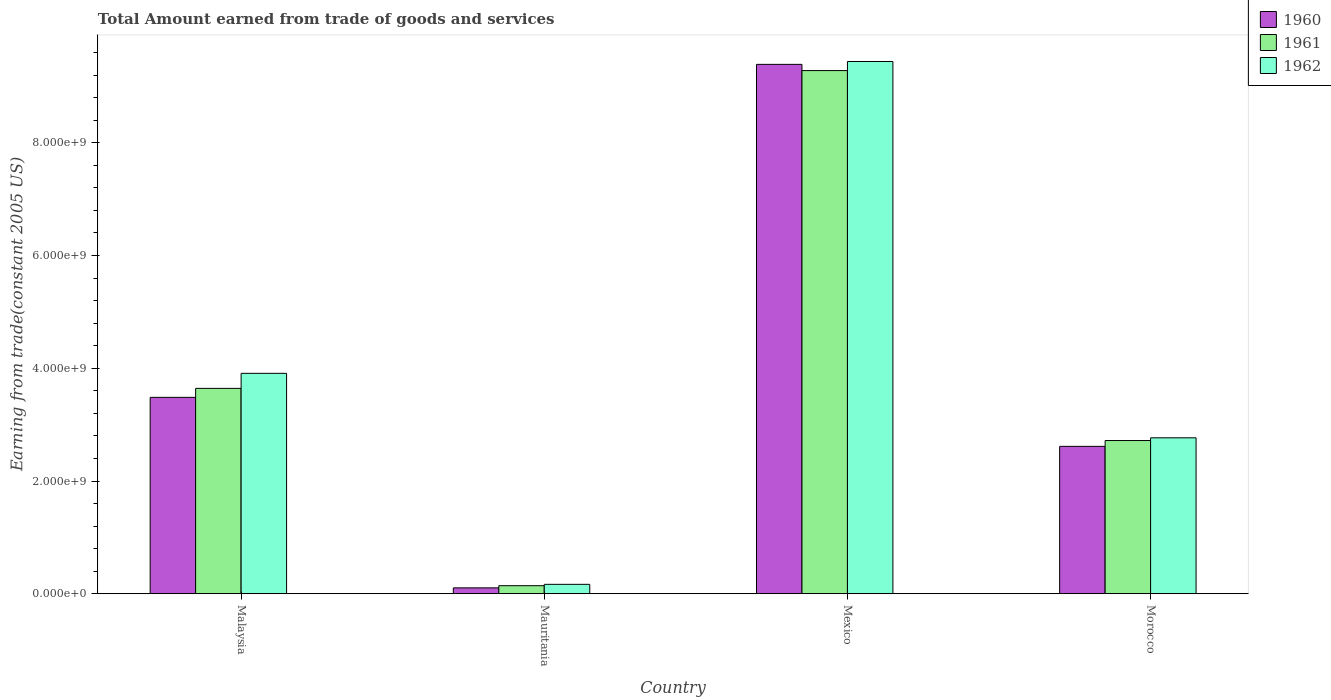How many different coloured bars are there?
Give a very brief answer. 3. Are the number of bars per tick equal to the number of legend labels?
Your answer should be compact. Yes. How many bars are there on the 3rd tick from the left?
Give a very brief answer. 3. How many bars are there on the 2nd tick from the right?
Provide a succinct answer. 3. In how many cases, is the number of bars for a given country not equal to the number of legend labels?
Give a very brief answer. 0. What is the total amount earned by trading goods and services in 1960 in Morocco?
Your response must be concise. 2.61e+09. Across all countries, what is the maximum total amount earned by trading goods and services in 1960?
Offer a terse response. 9.39e+09. Across all countries, what is the minimum total amount earned by trading goods and services in 1960?
Ensure brevity in your answer.  1.04e+08. In which country was the total amount earned by trading goods and services in 1962 maximum?
Your answer should be compact. Mexico. In which country was the total amount earned by trading goods and services in 1960 minimum?
Your answer should be compact. Mauritania. What is the total total amount earned by trading goods and services in 1961 in the graph?
Give a very brief answer. 1.58e+1. What is the difference between the total amount earned by trading goods and services in 1960 in Malaysia and that in Mexico?
Ensure brevity in your answer.  -5.91e+09. What is the difference between the total amount earned by trading goods and services in 1961 in Mauritania and the total amount earned by trading goods and services in 1960 in Malaysia?
Keep it short and to the point. -3.34e+09. What is the average total amount earned by trading goods and services in 1962 per country?
Your answer should be very brief. 4.07e+09. What is the difference between the total amount earned by trading goods and services of/in 1961 and total amount earned by trading goods and services of/in 1960 in Mauritania?
Ensure brevity in your answer.  3.85e+07. In how many countries, is the total amount earned by trading goods and services in 1960 greater than 400000000 US$?
Offer a terse response. 3. What is the ratio of the total amount earned by trading goods and services in 1960 in Malaysia to that in Mauritania?
Ensure brevity in your answer.  33.39. Is the total amount earned by trading goods and services in 1961 in Malaysia less than that in Mexico?
Provide a succinct answer. Yes. What is the difference between the highest and the second highest total amount earned by trading goods and services in 1962?
Provide a short and direct response. 5.53e+09. What is the difference between the highest and the lowest total amount earned by trading goods and services in 1961?
Offer a terse response. 9.14e+09. In how many countries, is the total amount earned by trading goods and services in 1960 greater than the average total amount earned by trading goods and services in 1960 taken over all countries?
Provide a short and direct response. 1. What does the 1st bar from the left in Morocco represents?
Provide a short and direct response. 1960. What does the 2nd bar from the right in Morocco represents?
Your response must be concise. 1961. Is it the case that in every country, the sum of the total amount earned by trading goods and services in 1960 and total amount earned by trading goods and services in 1962 is greater than the total amount earned by trading goods and services in 1961?
Your response must be concise. Yes. How many countries are there in the graph?
Keep it short and to the point. 4. What is the difference between two consecutive major ticks on the Y-axis?
Provide a succinct answer. 2.00e+09. Are the values on the major ticks of Y-axis written in scientific E-notation?
Keep it short and to the point. Yes. What is the title of the graph?
Make the answer very short. Total Amount earned from trade of goods and services. What is the label or title of the X-axis?
Provide a succinct answer. Country. What is the label or title of the Y-axis?
Your response must be concise. Earning from trade(constant 2005 US). What is the Earning from trade(constant 2005 US) of 1960 in Malaysia?
Your response must be concise. 3.48e+09. What is the Earning from trade(constant 2005 US) in 1961 in Malaysia?
Provide a short and direct response. 3.64e+09. What is the Earning from trade(constant 2005 US) in 1962 in Malaysia?
Your answer should be very brief. 3.91e+09. What is the Earning from trade(constant 2005 US) of 1960 in Mauritania?
Provide a succinct answer. 1.04e+08. What is the Earning from trade(constant 2005 US) of 1961 in Mauritania?
Your answer should be very brief. 1.43e+08. What is the Earning from trade(constant 2005 US) in 1962 in Mauritania?
Make the answer very short. 1.67e+08. What is the Earning from trade(constant 2005 US) in 1960 in Mexico?
Make the answer very short. 9.39e+09. What is the Earning from trade(constant 2005 US) of 1961 in Mexico?
Offer a terse response. 9.28e+09. What is the Earning from trade(constant 2005 US) in 1962 in Mexico?
Your answer should be compact. 9.44e+09. What is the Earning from trade(constant 2005 US) of 1960 in Morocco?
Offer a very short reply. 2.61e+09. What is the Earning from trade(constant 2005 US) of 1961 in Morocco?
Provide a short and direct response. 2.72e+09. What is the Earning from trade(constant 2005 US) in 1962 in Morocco?
Your answer should be very brief. 2.77e+09. Across all countries, what is the maximum Earning from trade(constant 2005 US) of 1960?
Give a very brief answer. 9.39e+09. Across all countries, what is the maximum Earning from trade(constant 2005 US) in 1961?
Make the answer very short. 9.28e+09. Across all countries, what is the maximum Earning from trade(constant 2005 US) in 1962?
Keep it short and to the point. 9.44e+09. Across all countries, what is the minimum Earning from trade(constant 2005 US) in 1960?
Give a very brief answer. 1.04e+08. Across all countries, what is the minimum Earning from trade(constant 2005 US) of 1961?
Offer a terse response. 1.43e+08. Across all countries, what is the minimum Earning from trade(constant 2005 US) in 1962?
Give a very brief answer. 1.67e+08. What is the total Earning from trade(constant 2005 US) of 1960 in the graph?
Ensure brevity in your answer.  1.56e+1. What is the total Earning from trade(constant 2005 US) in 1961 in the graph?
Provide a succinct answer. 1.58e+1. What is the total Earning from trade(constant 2005 US) in 1962 in the graph?
Offer a terse response. 1.63e+1. What is the difference between the Earning from trade(constant 2005 US) in 1960 in Malaysia and that in Mauritania?
Your response must be concise. 3.38e+09. What is the difference between the Earning from trade(constant 2005 US) in 1961 in Malaysia and that in Mauritania?
Provide a short and direct response. 3.50e+09. What is the difference between the Earning from trade(constant 2005 US) in 1962 in Malaysia and that in Mauritania?
Provide a short and direct response. 3.74e+09. What is the difference between the Earning from trade(constant 2005 US) of 1960 in Malaysia and that in Mexico?
Your answer should be very brief. -5.91e+09. What is the difference between the Earning from trade(constant 2005 US) of 1961 in Malaysia and that in Mexico?
Offer a very short reply. -5.64e+09. What is the difference between the Earning from trade(constant 2005 US) in 1962 in Malaysia and that in Mexico?
Offer a very short reply. -5.53e+09. What is the difference between the Earning from trade(constant 2005 US) of 1960 in Malaysia and that in Morocco?
Offer a very short reply. 8.69e+08. What is the difference between the Earning from trade(constant 2005 US) in 1961 in Malaysia and that in Morocco?
Ensure brevity in your answer.  9.25e+08. What is the difference between the Earning from trade(constant 2005 US) in 1962 in Malaysia and that in Morocco?
Your answer should be very brief. 1.14e+09. What is the difference between the Earning from trade(constant 2005 US) in 1960 in Mauritania and that in Mexico?
Your answer should be compact. -9.29e+09. What is the difference between the Earning from trade(constant 2005 US) of 1961 in Mauritania and that in Mexico?
Keep it short and to the point. -9.14e+09. What is the difference between the Earning from trade(constant 2005 US) in 1962 in Mauritania and that in Mexico?
Give a very brief answer. -9.28e+09. What is the difference between the Earning from trade(constant 2005 US) of 1960 in Mauritania and that in Morocco?
Ensure brevity in your answer.  -2.51e+09. What is the difference between the Earning from trade(constant 2005 US) in 1961 in Mauritania and that in Morocco?
Give a very brief answer. -2.58e+09. What is the difference between the Earning from trade(constant 2005 US) in 1962 in Mauritania and that in Morocco?
Your answer should be compact. -2.60e+09. What is the difference between the Earning from trade(constant 2005 US) of 1960 in Mexico and that in Morocco?
Provide a succinct answer. 6.78e+09. What is the difference between the Earning from trade(constant 2005 US) of 1961 in Mexico and that in Morocco?
Make the answer very short. 6.56e+09. What is the difference between the Earning from trade(constant 2005 US) of 1962 in Mexico and that in Morocco?
Give a very brief answer. 6.68e+09. What is the difference between the Earning from trade(constant 2005 US) in 1960 in Malaysia and the Earning from trade(constant 2005 US) in 1961 in Mauritania?
Offer a terse response. 3.34e+09. What is the difference between the Earning from trade(constant 2005 US) in 1960 in Malaysia and the Earning from trade(constant 2005 US) in 1962 in Mauritania?
Your answer should be compact. 3.32e+09. What is the difference between the Earning from trade(constant 2005 US) of 1961 in Malaysia and the Earning from trade(constant 2005 US) of 1962 in Mauritania?
Give a very brief answer. 3.48e+09. What is the difference between the Earning from trade(constant 2005 US) of 1960 in Malaysia and the Earning from trade(constant 2005 US) of 1961 in Mexico?
Give a very brief answer. -5.80e+09. What is the difference between the Earning from trade(constant 2005 US) of 1960 in Malaysia and the Earning from trade(constant 2005 US) of 1962 in Mexico?
Give a very brief answer. -5.96e+09. What is the difference between the Earning from trade(constant 2005 US) of 1961 in Malaysia and the Earning from trade(constant 2005 US) of 1962 in Mexico?
Provide a succinct answer. -5.80e+09. What is the difference between the Earning from trade(constant 2005 US) of 1960 in Malaysia and the Earning from trade(constant 2005 US) of 1961 in Morocco?
Your response must be concise. 7.66e+08. What is the difference between the Earning from trade(constant 2005 US) in 1960 in Malaysia and the Earning from trade(constant 2005 US) in 1962 in Morocco?
Give a very brief answer. 7.17e+08. What is the difference between the Earning from trade(constant 2005 US) in 1961 in Malaysia and the Earning from trade(constant 2005 US) in 1962 in Morocco?
Ensure brevity in your answer.  8.77e+08. What is the difference between the Earning from trade(constant 2005 US) of 1960 in Mauritania and the Earning from trade(constant 2005 US) of 1961 in Mexico?
Ensure brevity in your answer.  -9.18e+09. What is the difference between the Earning from trade(constant 2005 US) of 1960 in Mauritania and the Earning from trade(constant 2005 US) of 1962 in Mexico?
Keep it short and to the point. -9.34e+09. What is the difference between the Earning from trade(constant 2005 US) in 1961 in Mauritania and the Earning from trade(constant 2005 US) in 1962 in Mexico?
Provide a succinct answer. -9.30e+09. What is the difference between the Earning from trade(constant 2005 US) of 1960 in Mauritania and the Earning from trade(constant 2005 US) of 1961 in Morocco?
Keep it short and to the point. -2.61e+09. What is the difference between the Earning from trade(constant 2005 US) in 1960 in Mauritania and the Earning from trade(constant 2005 US) in 1962 in Morocco?
Ensure brevity in your answer.  -2.66e+09. What is the difference between the Earning from trade(constant 2005 US) in 1961 in Mauritania and the Earning from trade(constant 2005 US) in 1962 in Morocco?
Provide a succinct answer. -2.62e+09. What is the difference between the Earning from trade(constant 2005 US) in 1960 in Mexico and the Earning from trade(constant 2005 US) in 1961 in Morocco?
Offer a very short reply. 6.67e+09. What is the difference between the Earning from trade(constant 2005 US) in 1960 in Mexico and the Earning from trade(constant 2005 US) in 1962 in Morocco?
Offer a terse response. 6.63e+09. What is the difference between the Earning from trade(constant 2005 US) of 1961 in Mexico and the Earning from trade(constant 2005 US) of 1962 in Morocco?
Offer a terse response. 6.51e+09. What is the average Earning from trade(constant 2005 US) in 1960 per country?
Your answer should be very brief. 3.90e+09. What is the average Earning from trade(constant 2005 US) of 1961 per country?
Make the answer very short. 3.95e+09. What is the average Earning from trade(constant 2005 US) in 1962 per country?
Provide a short and direct response. 4.07e+09. What is the difference between the Earning from trade(constant 2005 US) of 1960 and Earning from trade(constant 2005 US) of 1961 in Malaysia?
Your answer should be compact. -1.60e+08. What is the difference between the Earning from trade(constant 2005 US) in 1960 and Earning from trade(constant 2005 US) in 1962 in Malaysia?
Keep it short and to the point. -4.26e+08. What is the difference between the Earning from trade(constant 2005 US) of 1961 and Earning from trade(constant 2005 US) of 1962 in Malaysia?
Ensure brevity in your answer.  -2.67e+08. What is the difference between the Earning from trade(constant 2005 US) in 1960 and Earning from trade(constant 2005 US) in 1961 in Mauritania?
Make the answer very short. -3.85e+07. What is the difference between the Earning from trade(constant 2005 US) of 1960 and Earning from trade(constant 2005 US) of 1962 in Mauritania?
Provide a short and direct response. -6.27e+07. What is the difference between the Earning from trade(constant 2005 US) in 1961 and Earning from trade(constant 2005 US) in 1962 in Mauritania?
Offer a terse response. -2.42e+07. What is the difference between the Earning from trade(constant 2005 US) in 1960 and Earning from trade(constant 2005 US) in 1961 in Mexico?
Your response must be concise. 1.10e+08. What is the difference between the Earning from trade(constant 2005 US) of 1960 and Earning from trade(constant 2005 US) of 1962 in Mexico?
Provide a short and direct response. -5.10e+07. What is the difference between the Earning from trade(constant 2005 US) in 1961 and Earning from trade(constant 2005 US) in 1962 in Mexico?
Ensure brevity in your answer.  -1.61e+08. What is the difference between the Earning from trade(constant 2005 US) in 1960 and Earning from trade(constant 2005 US) in 1961 in Morocco?
Provide a short and direct response. -1.03e+08. What is the difference between the Earning from trade(constant 2005 US) of 1960 and Earning from trade(constant 2005 US) of 1962 in Morocco?
Provide a short and direct response. -1.52e+08. What is the difference between the Earning from trade(constant 2005 US) in 1961 and Earning from trade(constant 2005 US) in 1962 in Morocco?
Ensure brevity in your answer.  -4.82e+07. What is the ratio of the Earning from trade(constant 2005 US) of 1960 in Malaysia to that in Mauritania?
Keep it short and to the point. 33.39. What is the ratio of the Earning from trade(constant 2005 US) of 1961 in Malaysia to that in Mauritania?
Provide a short and direct response. 25.51. What is the ratio of the Earning from trade(constant 2005 US) in 1962 in Malaysia to that in Mauritania?
Ensure brevity in your answer.  23.41. What is the ratio of the Earning from trade(constant 2005 US) of 1960 in Malaysia to that in Mexico?
Ensure brevity in your answer.  0.37. What is the ratio of the Earning from trade(constant 2005 US) in 1961 in Malaysia to that in Mexico?
Ensure brevity in your answer.  0.39. What is the ratio of the Earning from trade(constant 2005 US) in 1962 in Malaysia to that in Mexico?
Provide a short and direct response. 0.41. What is the ratio of the Earning from trade(constant 2005 US) in 1960 in Malaysia to that in Morocco?
Give a very brief answer. 1.33. What is the ratio of the Earning from trade(constant 2005 US) in 1961 in Malaysia to that in Morocco?
Your answer should be compact. 1.34. What is the ratio of the Earning from trade(constant 2005 US) in 1962 in Malaysia to that in Morocco?
Offer a very short reply. 1.41. What is the ratio of the Earning from trade(constant 2005 US) of 1960 in Mauritania to that in Mexico?
Make the answer very short. 0.01. What is the ratio of the Earning from trade(constant 2005 US) of 1961 in Mauritania to that in Mexico?
Provide a short and direct response. 0.02. What is the ratio of the Earning from trade(constant 2005 US) of 1962 in Mauritania to that in Mexico?
Your answer should be very brief. 0.02. What is the ratio of the Earning from trade(constant 2005 US) in 1960 in Mauritania to that in Morocco?
Make the answer very short. 0.04. What is the ratio of the Earning from trade(constant 2005 US) in 1961 in Mauritania to that in Morocco?
Your answer should be very brief. 0.05. What is the ratio of the Earning from trade(constant 2005 US) of 1962 in Mauritania to that in Morocco?
Provide a short and direct response. 0.06. What is the ratio of the Earning from trade(constant 2005 US) of 1960 in Mexico to that in Morocco?
Your response must be concise. 3.59. What is the ratio of the Earning from trade(constant 2005 US) of 1961 in Mexico to that in Morocco?
Give a very brief answer. 3.41. What is the ratio of the Earning from trade(constant 2005 US) in 1962 in Mexico to that in Morocco?
Provide a short and direct response. 3.41. What is the difference between the highest and the second highest Earning from trade(constant 2005 US) of 1960?
Give a very brief answer. 5.91e+09. What is the difference between the highest and the second highest Earning from trade(constant 2005 US) in 1961?
Provide a succinct answer. 5.64e+09. What is the difference between the highest and the second highest Earning from trade(constant 2005 US) in 1962?
Your answer should be compact. 5.53e+09. What is the difference between the highest and the lowest Earning from trade(constant 2005 US) in 1960?
Your answer should be very brief. 9.29e+09. What is the difference between the highest and the lowest Earning from trade(constant 2005 US) in 1961?
Your response must be concise. 9.14e+09. What is the difference between the highest and the lowest Earning from trade(constant 2005 US) in 1962?
Give a very brief answer. 9.28e+09. 